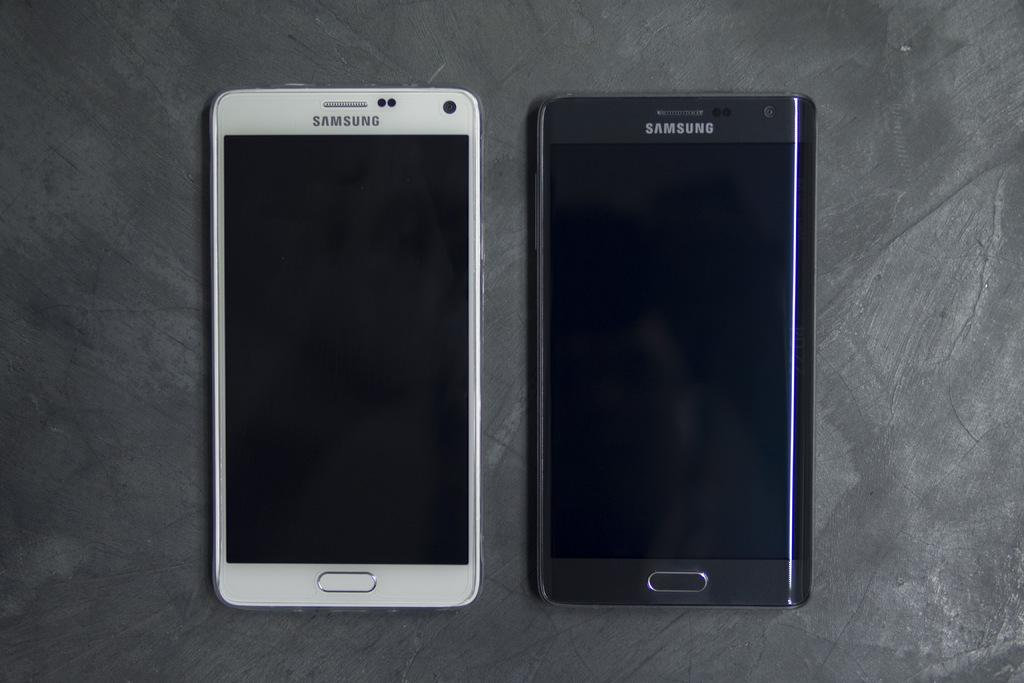<image>
Create a compact narrative representing the image presented. Two phones that say Samsung, they are white and black 